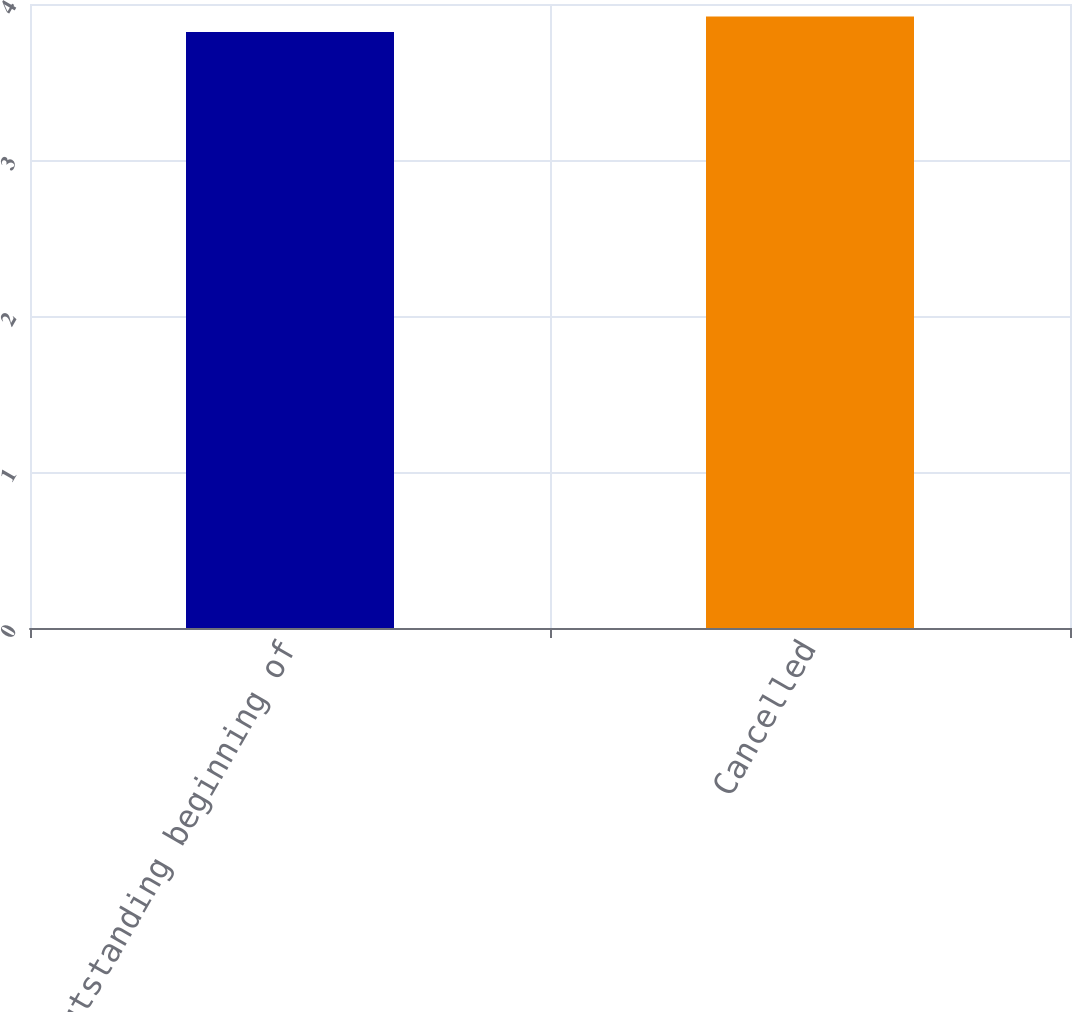Convert chart to OTSL. <chart><loc_0><loc_0><loc_500><loc_500><bar_chart><fcel>Outstanding beginning of<fcel>Cancelled<nl><fcel>3.82<fcel>3.92<nl></chart> 